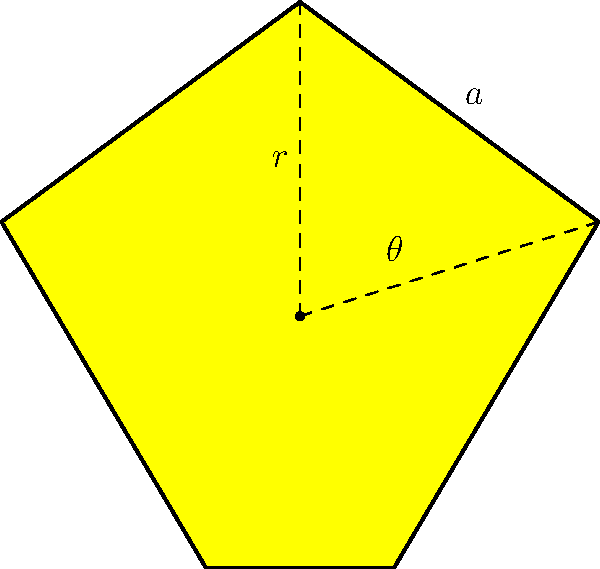A star-shaped religious symbol is formed by five identical isosceles triangles. The radius $r$ from the center to any point of the star is 2 units, and the angle $\theta$ between two adjacent radii is $\frac{2\pi}{5}$. Calculate the total area of the star symbol, expressing your answer in terms of $\sin(\frac{\pi}{5})$. To find the area of the star, we can follow these steps:

1) First, we need to find the area of one isosceles triangle that forms the star's point.

2) The base angle of this isosceles triangle is $\frac{\theta}{2} = \frac{\pi}{5}$.

3) The area of this triangle can be calculated using the formula:
   $$A_{\text{triangle}} = \frac{1}{2} \cdot r^2 \cdot \sin(\frac{\theta}{2})$$

4) Substituting the values:
   $$A_{\text{triangle}} = \frac{1}{2} \cdot 2^2 \cdot \sin(\frac{\pi}{5}) = 2\sin(\frac{\pi}{5})$$

5) The star consists of 5 such triangles, so the total area is:
   $$A_{\text{star}} = 5 \cdot A_{\text{triangle}} = 5 \cdot 2\sin(\frac{\pi}{5}) = 10\sin(\frac{\pi}{5})$$

Thus, the area of the star-shaped symbol is $10\sin(\frac{\pi}{5})$ square units.
Answer: $10\sin(\frac{\pi}{5})$ square units 